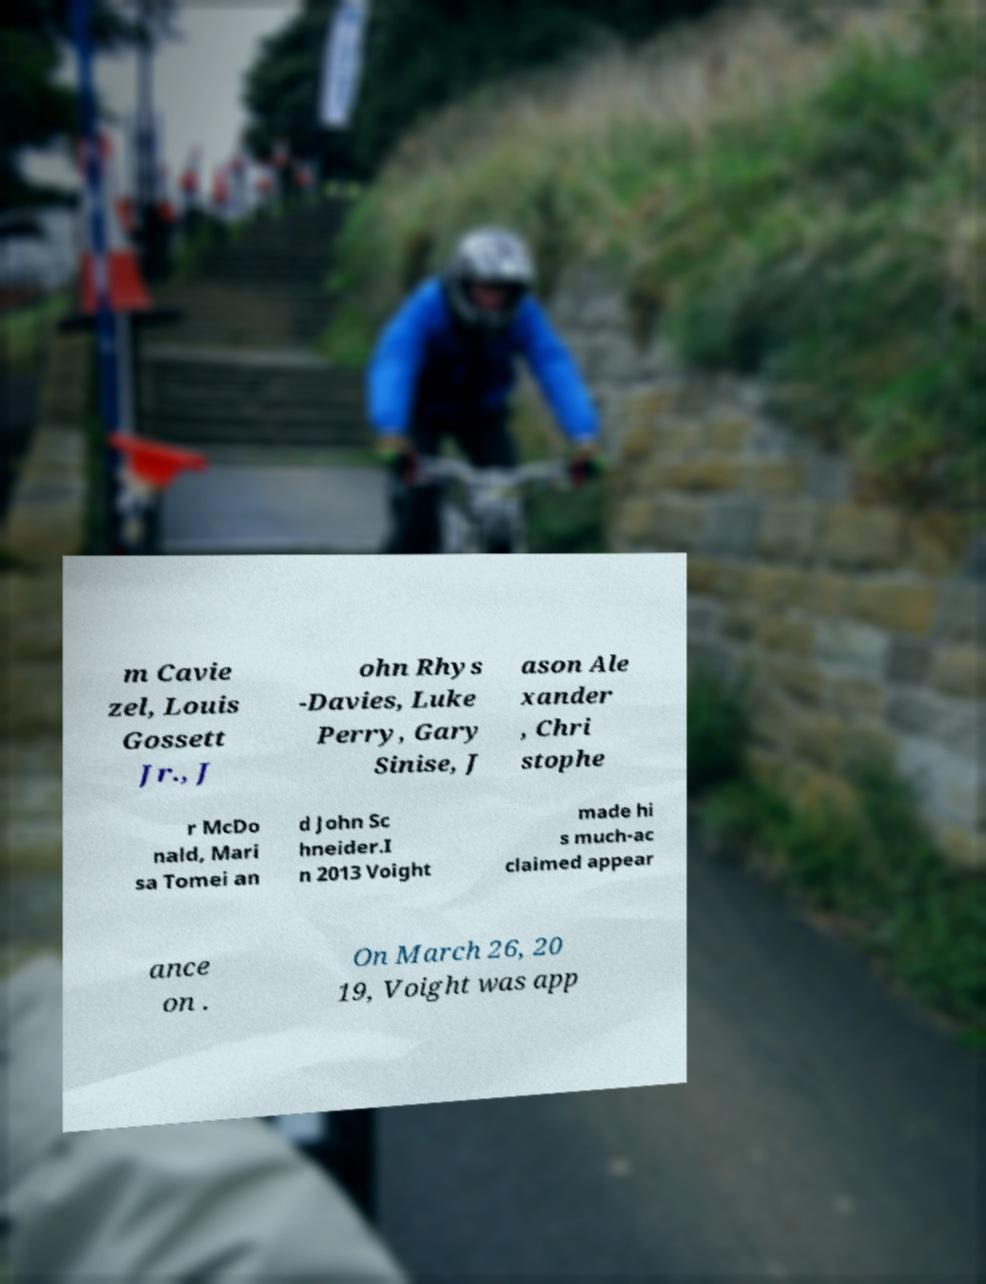Please read and relay the text visible in this image. What does it say? m Cavie zel, Louis Gossett Jr., J ohn Rhys -Davies, Luke Perry, Gary Sinise, J ason Ale xander , Chri stophe r McDo nald, Mari sa Tomei an d John Sc hneider.I n 2013 Voight made hi s much-ac claimed appear ance on . On March 26, 20 19, Voight was app 